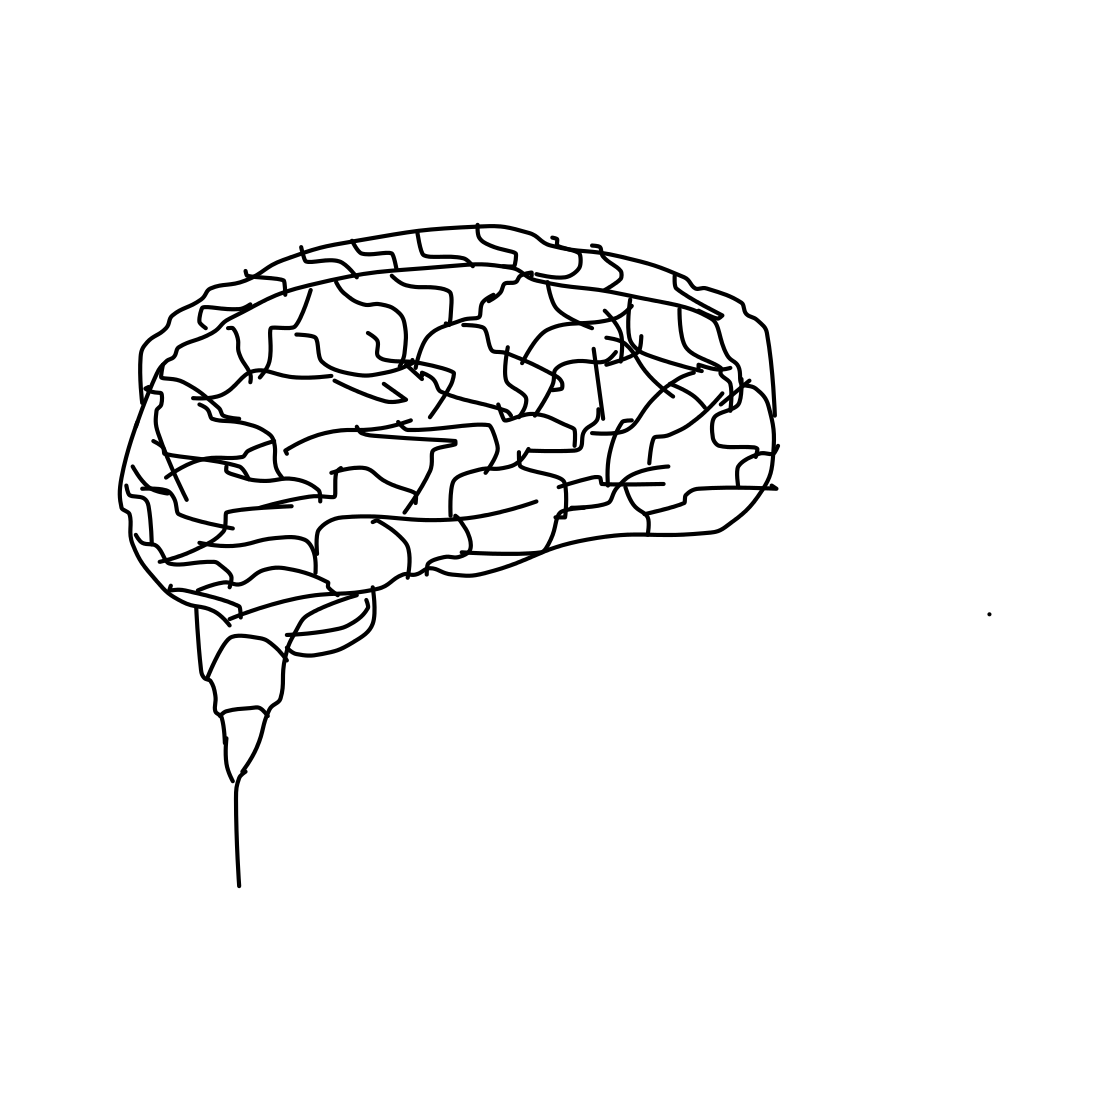In the scene, is a pen in it? No 